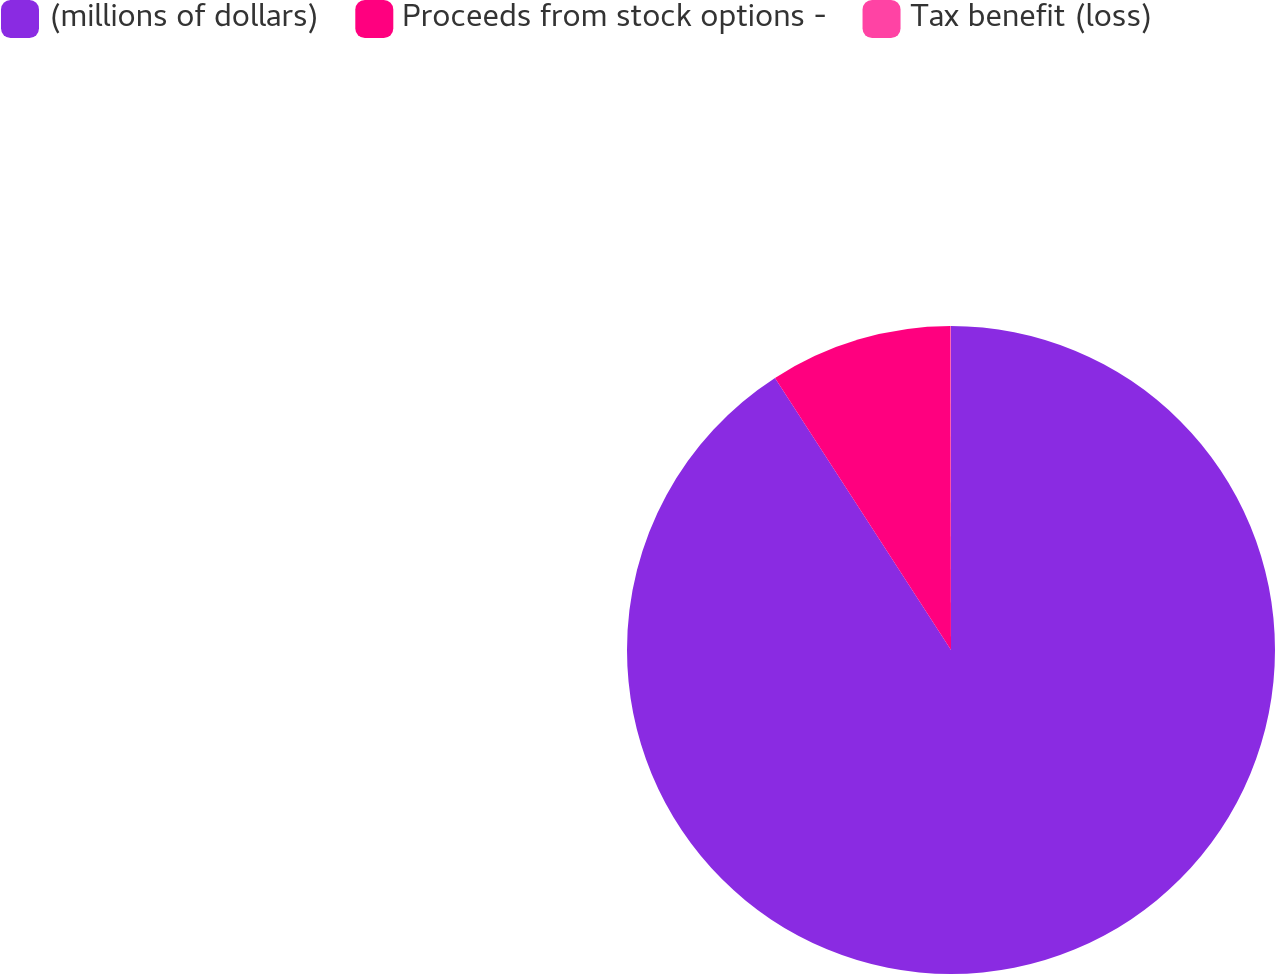Convert chart to OTSL. <chart><loc_0><loc_0><loc_500><loc_500><pie_chart><fcel>(millions of dollars)<fcel>Proceeds from stock options -<fcel>Tax benefit (loss)<nl><fcel>90.85%<fcel>9.11%<fcel>0.03%<nl></chart> 